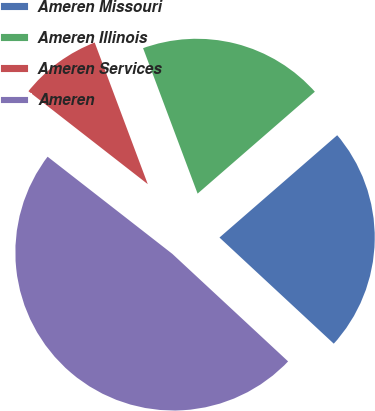Convert chart. <chart><loc_0><loc_0><loc_500><loc_500><pie_chart><fcel>Ameren Missouri<fcel>Ameren Illinois<fcel>Ameren Services<fcel>Ameren<nl><fcel>23.3%<fcel>19.32%<fcel>8.76%<fcel>48.62%<nl></chart> 